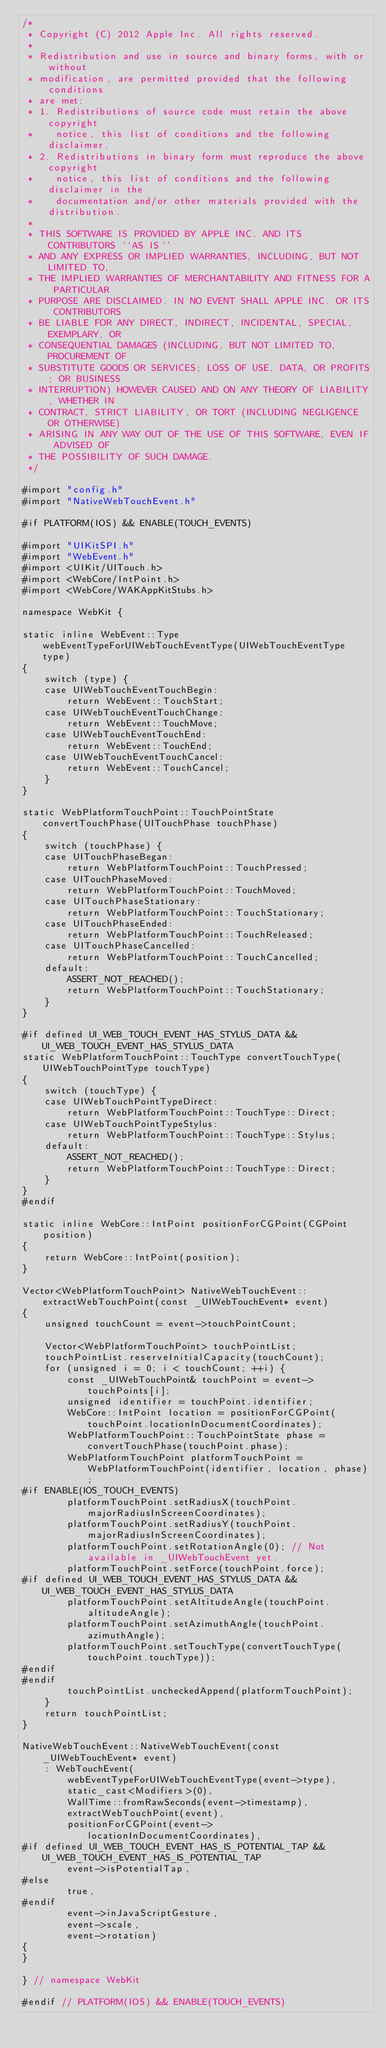<code> <loc_0><loc_0><loc_500><loc_500><_ObjectiveC_>/*
 * Copyright (C) 2012 Apple Inc. All rights reserved.
 *
 * Redistribution and use in source and binary forms, with or without
 * modification, are permitted provided that the following conditions
 * are met:
 * 1. Redistributions of source code must retain the above copyright
 *    notice, this list of conditions and the following disclaimer.
 * 2. Redistributions in binary form must reproduce the above copyright
 *    notice, this list of conditions and the following disclaimer in the
 *    documentation and/or other materials provided with the distribution.
 *
 * THIS SOFTWARE IS PROVIDED BY APPLE INC. AND ITS CONTRIBUTORS ``AS IS''
 * AND ANY EXPRESS OR IMPLIED WARRANTIES, INCLUDING, BUT NOT LIMITED TO,
 * THE IMPLIED WARRANTIES OF MERCHANTABILITY AND FITNESS FOR A PARTICULAR
 * PURPOSE ARE DISCLAIMED. IN NO EVENT SHALL APPLE INC. OR ITS CONTRIBUTORS
 * BE LIABLE FOR ANY DIRECT, INDIRECT, INCIDENTAL, SPECIAL, EXEMPLARY, OR
 * CONSEQUENTIAL DAMAGES (INCLUDING, BUT NOT LIMITED TO, PROCUREMENT OF
 * SUBSTITUTE GOODS OR SERVICES; LOSS OF USE, DATA, OR PROFITS; OR BUSINESS
 * INTERRUPTION) HOWEVER CAUSED AND ON ANY THEORY OF LIABILITY, WHETHER IN
 * CONTRACT, STRICT LIABILITY, OR TORT (INCLUDING NEGLIGENCE OR OTHERWISE)
 * ARISING IN ANY WAY OUT OF THE USE OF THIS SOFTWARE, EVEN IF ADVISED OF
 * THE POSSIBILITY OF SUCH DAMAGE.
 */

#import "config.h"
#import "NativeWebTouchEvent.h"

#if PLATFORM(IOS) && ENABLE(TOUCH_EVENTS)

#import "UIKitSPI.h"
#import "WebEvent.h"
#import <UIKit/UITouch.h>
#import <WebCore/IntPoint.h>
#import <WebCore/WAKAppKitStubs.h>

namespace WebKit {

static inline WebEvent::Type webEventTypeForUIWebTouchEventType(UIWebTouchEventType type)
{
    switch (type) {
    case UIWebTouchEventTouchBegin:
        return WebEvent::TouchStart;
    case UIWebTouchEventTouchChange:
        return WebEvent::TouchMove;
    case UIWebTouchEventTouchEnd:
        return WebEvent::TouchEnd;
    case UIWebTouchEventTouchCancel:
        return WebEvent::TouchCancel;
    }
}

static WebPlatformTouchPoint::TouchPointState convertTouchPhase(UITouchPhase touchPhase)
{
    switch (touchPhase) {
    case UITouchPhaseBegan:
        return WebPlatformTouchPoint::TouchPressed;
    case UITouchPhaseMoved:
        return WebPlatformTouchPoint::TouchMoved;
    case UITouchPhaseStationary:
        return WebPlatformTouchPoint::TouchStationary;
    case UITouchPhaseEnded:
        return WebPlatformTouchPoint::TouchReleased;
    case UITouchPhaseCancelled:
        return WebPlatformTouchPoint::TouchCancelled;
    default:
        ASSERT_NOT_REACHED();
        return WebPlatformTouchPoint::TouchStationary;
    }
}

#if defined UI_WEB_TOUCH_EVENT_HAS_STYLUS_DATA && UI_WEB_TOUCH_EVENT_HAS_STYLUS_DATA
static WebPlatformTouchPoint::TouchType convertTouchType(UIWebTouchPointType touchType)
{
    switch (touchType) {
    case UIWebTouchPointTypeDirect:
        return WebPlatformTouchPoint::TouchType::Direct;
    case UIWebTouchPointTypeStylus:
        return WebPlatformTouchPoint::TouchType::Stylus;
    default:
        ASSERT_NOT_REACHED();
        return WebPlatformTouchPoint::TouchType::Direct;
    }
}
#endif

static inline WebCore::IntPoint positionForCGPoint(CGPoint position)
{
    return WebCore::IntPoint(position);
}

Vector<WebPlatformTouchPoint> NativeWebTouchEvent::extractWebTouchPoint(const _UIWebTouchEvent* event)
{
    unsigned touchCount = event->touchPointCount;

    Vector<WebPlatformTouchPoint> touchPointList;
    touchPointList.reserveInitialCapacity(touchCount);
    for (unsigned i = 0; i < touchCount; ++i) {
        const _UIWebTouchPoint& touchPoint = event->touchPoints[i];
        unsigned identifier = touchPoint.identifier;
        WebCore::IntPoint location = positionForCGPoint(touchPoint.locationInDocumentCoordinates);
        WebPlatformTouchPoint::TouchPointState phase = convertTouchPhase(touchPoint.phase);
        WebPlatformTouchPoint platformTouchPoint = WebPlatformTouchPoint(identifier, location, phase);
#if ENABLE(IOS_TOUCH_EVENTS)
        platformTouchPoint.setRadiusX(touchPoint.majorRadiusInScreenCoordinates);
        platformTouchPoint.setRadiusY(touchPoint.majorRadiusInScreenCoordinates);
        platformTouchPoint.setRotationAngle(0); // Not available in _UIWebTouchEvent yet.
        platformTouchPoint.setForce(touchPoint.force);
#if defined UI_WEB_TOUCH_EVENT_HAS_STYLUS_DATA && UI_WEB_TOUCH_EVENT_HAS_STYLUS_DATA
        platformTouchPoint.setAltitudeAngle(touchPoint.altitudeAngle);
        platformTouchPoint.setAzimuthAngle(touchPoint.azimuthAngle);
        platformTouchPoint.setTouchType(convertTouchType(touchPoint.touchType));
#endif
#endif
        touchPointList.uncheckedAppend(platformTouchPoint);
    }
    return touchPointList;
}

NativeWebTouchEvent::NativeWebTouchEvent(const _UIWebTouchEvent* event)
    : WebTouchEvent(
        webEventTypeForUIWebTouchEventType(event->type),
        static_cast<Modifiers>(0),
        WallTime::fromRawSeconds(event->timestamp),
        extractWebTouchPoint(event),
        positionForCGPoint(event->locationInDocumentCoordinates),
#if defined UI_WEB_TOUCH_EVENT_HAS_IS_POTENTIAL_TAP && UI_WEB_TOUCH_EVENT_HAS_IS_POTENTIAL_TAP
        event->isPotentialTap,
#else
        true,
#endif
        event->inJavaScriptGesture,
        event->scale,
        event->rotation)
{
}

} // namespace WebKit

#endif // PLATFORM(IOS) && ENABLE(TOUCH_EVENTS)
</code> 